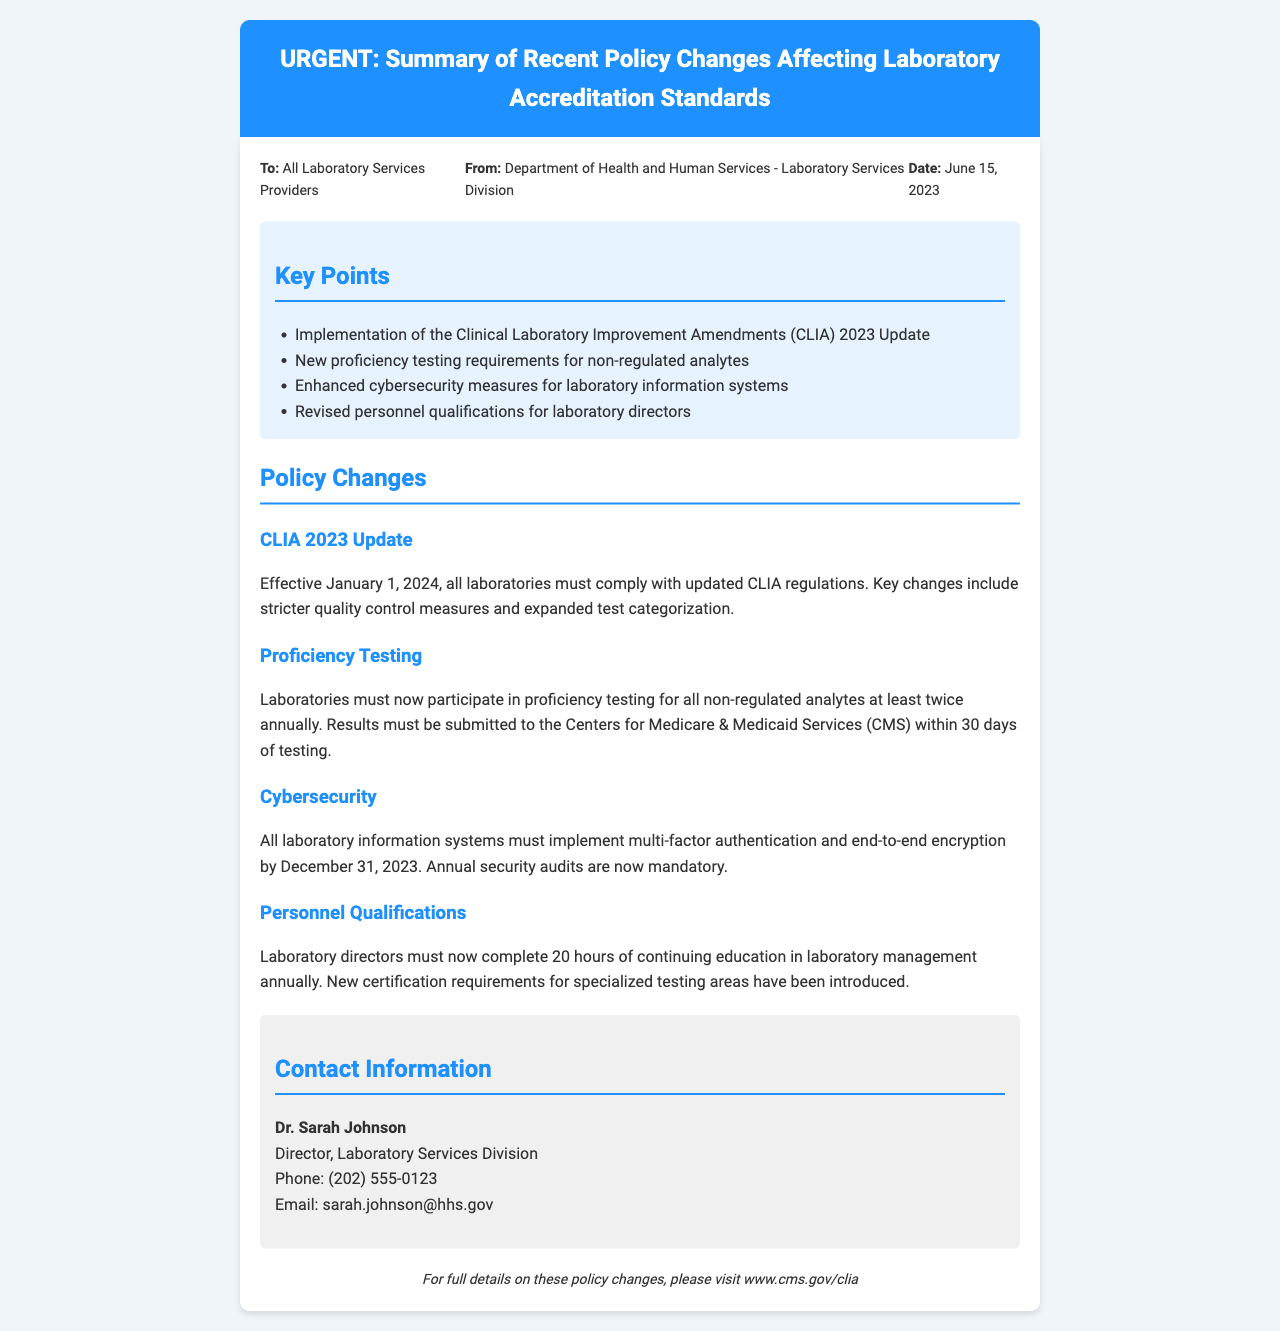What is the date of the fax? The date of the fax is provided in the meta-info section as June 15, 2023.
Answer: June 15, 2023 Who is the sender of the fax? The sender of the fax is mentioned in the meta-info section as the Department of Health and Human Services - Laboratory Services Division.
Answer: Department of Health and Human Services - Laboratory Services Division What is the key change in CLIA 2023 Update? The key change mentioned for CLIA 2023 Update is stricter quality control measures and expanded test categorization.
Answer: Stricter quality control measures and expanded test categorization When must laboratories comply with the CLIA 2023 regulations? The document states that compliance with the CLIA 2023 regulations is required effective January 1, 2024.
Answer: January 1, 2024 What are the new proficiency testing requirements? The proficiency testing requirements state that laboratories must participate in proficiency testing for all non-regulated analytes at least twice annually.
Answer: At least twice annually What is the deadline for implementing cybersecurity measures? The document specifies that multi-factor authentication and end-to-end encryption must be implemented by December 31, 2023.
Answer: December 31, 2023 How many hours of continuing education must laboratory directors complete annually? The document mentions that laboratory directors must complete 20 hours of continuing education annually.
Answer: 20 hours What is the email contact for Dr. Sarah Johnson? The email contact for Dr. Sarah Johnson is provided in the contact information section of the fax.
Answer: sarah.johnson@hhs.gov What must laboratories submit to CMS after proficiency testing? Laboratories must submit their proficiency testing results to the Centers for Medicare & Medicaid Services within 30 days of testing.
Answer: Within 30 days 